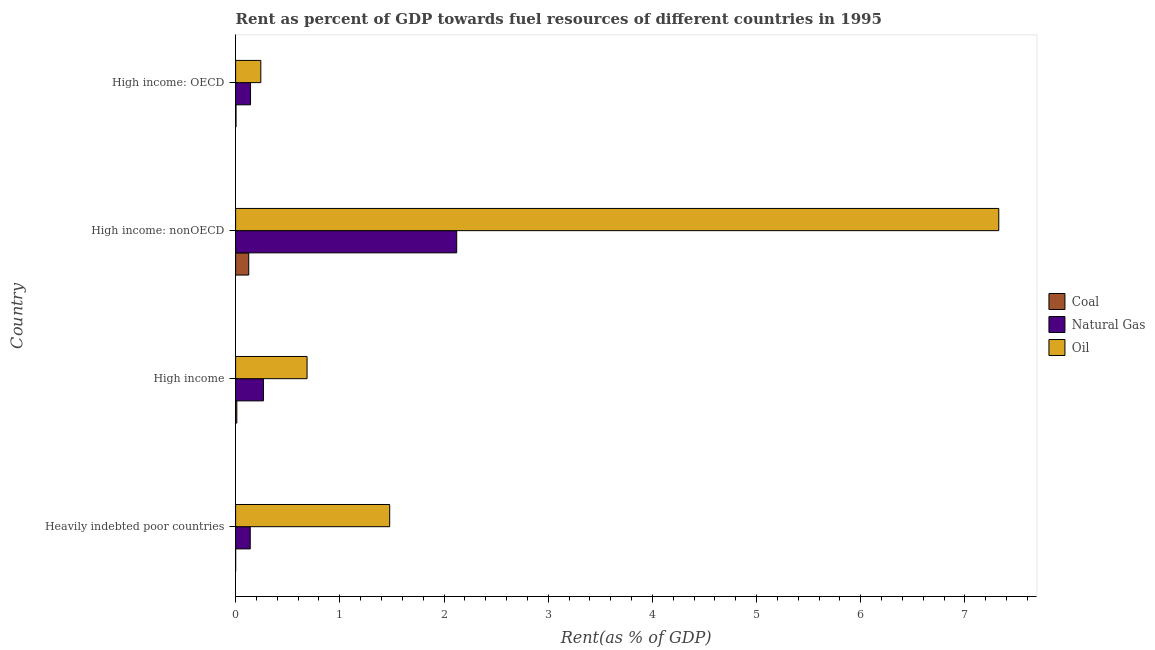How many different coloured bars are there?
Your answer should be compact. 3. How many groups of bars are there?
Your answer should be compact. 4. Are the number of bars per tick equal to the number of legend labels?
Your answer should be very brief. Yes. Are the number of bars on each tick of the Y-axis equal?
Keep it short and to the point. Yes. How many bars are there on the 1st tick from the top?
Provide a short and direct response. 3. What is the label of the 4th group of bars from the top?
Ensure brevity in your answer.  Heavily indebted poor countries. In how many cases, is the number of bars for a given country not equal to the number of legend labels?
Make the answer very short. 0. What is the rent towards natural gas in High income: OECD?
Offer a terse response. 0.14. Across all countries, what is the maximum rent towards coal?
Keep it short and to the point. 0.13. Across all countries, what is the minimum rent towards oil?
Ensure brevity in your answer.  0.24. In which country was the rent towards coal maximum?
Your answer should be compact. High income: nonOECD. In which country was the rent towards natural gas minimum?
Your answer should be very brief. Heavily indebted poor countries. What is the total rent towards coal in the graph?
Your answer should be very brief. 0.14. What is the difference between the rent towards coal in Heavily indebted poor countries and that in High income: nonOECD?
Your answer should be compact. -0.13. What is the difference between the rent towards coal in High income: OECD and the rent towards natural gas in High income: nonOECD?
Give a very brief answer. -2.12. What is the average rent towards natural gas per country?
Ensure brevity in your answer.  0.67. What is the difference between the rent towards coal and rent towards natural gas in High income?
Make the answer very short. -0.26. Is the rent towards coal in High income: OECD less than that in High income: nonOECD?
Your response must be concise. Yes. What is the difference between the highest and the second highest rent towards coal?
Your answer should be very brief. 0.11. What is the difference between the highest and the lowest rent towards natural gas?
Ensure brevity in your answer.  1.98. Is the sum of the rent towards coal in High income: OECD and High income: nonOECD greater than the maximum rent towards natural gas across all countries?
Your answer should be very brief. No. What does the 2nd bar from the top in High income represents?
Provide a succinct answer. Natural Gas. What does the 3rd bar from the bottom in High income represents?
Ensure brevity in your answer.  Oil. How many bars are there?
Provide a succinct answer. 12. Are all the bars in the graph horizontal?
Offer a very short reply. Yes. How many countries are there in the graph?
Provide a short and direct response. 4. Does the graph contain any zero values?
Your answer should be very brief. No. Where does the legend appear in the graph?
Your answer should be compact. Center right. What is the title of the graph?
Your response must be concise. Rent as percent of GDP towards fuel resources of different countries in 1995. What is the label or title of the X-axis?
Make the answer very short. Rent(as % of GDP). What is the label or title of the Y-axis?
Give a very brief answer. Country. What is the Rent(as % of GDP) of Coal in Heavily indebted poor countries?
Offer a terse response. 3.12441298974557e-5. What is the Rent(as % of GDP) of Natural Gas in Heavily indebted poor countries?
Offer a terse response. 0.14. What is the Rent(as % of GDP) in Oil in Heavily indebted poor countries?
Keep it short and to the point. 1.48. What is the Rent(as % of GDP) in Coal in High income?
Give a very brief answer. 0.01. What is the Rent(as % of GDP) of Natural Gas in High income?
Offer a terse response. 0.27. What is the Rent(as % of GDP) in Oil in High income?
Provide a short and direct response. 0.69. What is the Rent(as % of GDP) of Coal in High income: nonOECD?
Your response must be concise. 0.13. What is the Rent(as % of GDP) of Natural Gas in High income: nonOECD?
Offer a very short reply. 2.12. What is the Rent(as % of GDP) in Oil in High income: nonOECD?
Provide a short and direct response. 7.32. What is the Rent(as % of GDP) in Coal in High income: OECD?
Your answer should be very brief. 0. What is the Rent(as % of GDP) in Natural Gas in High income: OECD?
Offer a terse response. 0.14. What is the Rent(as % of GDP) in Oil in High income: OECD?
Provide a short and direct response. 0.24. Across all countries, what is the maximum Rent(as % of GDP) of Coal?
Offer a very short reply. 0.13. Across all countries, what is the maximum Rent(as % of GDP) of Natural Gas?
Your answer should be very brief. 2.12. Across all countries, what is the maximum Rent(as % of GDP) in Oil?
Your answer should be very brief. 7.32. Across all countries, what is the minimum Rent(as % of GDP) in Coal?
Offer a terse response. 3.12441298974557e-5. Across all countries, what is the minimum Rent(as % of GDP) of Natural Gas?
Provide a short and direct response. 0.14. Across all countries, what is the minimum Rent(as % of GDP) of Oil?
Offer a very short reply. 0.24. What is the total Rent(as % of GDP) of Coal in the graph?
Provide a succinct answer. 0.14. What is the total Rent(as % of GDP) of Natural Gas in the graph?
Your response must be concise. 2.67. What is the total Rent(as % of GDP) in Oil in the graph?
Give a very brief answer. 9.73. What is the difference between the Rent(as % of GDP) of Coal in Heavily indebted poor countries and that in High income?
Offer a very short reply. -0.01. What is the difference between the Rent(as % of GDP) in Natural Gas in Heavily indebted poor countries and that in High income?
Your response must be concise. -0.13. What is the difference between the Rent(as % of GDP) of Oil in Heavily indebted poor countries and that in High income?
Provide a succinct answer. 0.79. What is the difference between the Rent(as % of GDP) in Coal in Heavily indebted poor countries and that in High income: nonOECD?
Your answer should be very brief. -0.13. What is the difference between the Rent(as % of GDP) of Natural Gas in Heavily indebted poor countries and that in High income: nonOECD?
Make the answer very short. -1.98. What is the difference between the Rent(as % of GDP) of Oil in Heavily indebted poor countries and that in High income: nonOECD?
Your answer should be very brief. -5.85. What is the difference between the Rent(as % of GDP) in Coal in Heavily indebted poor countries and that in High income: OECD?
Ensure brevity in your answer.  -0. What is the difference between the Rent(as % of GDP) of Natural Gas in Heavily indebted poor countries and that in High income: OECD?
Your response must be concise. -0. What is the difference between the Rent(as % of GDP) in Oil in Heavily indebted poor countries and that in High income: OECD?
Your response must be concise. 1.24. What is the difference between the Rent(as % of GDP) of Coal in High income and that in High income: nonOECD?
Make the answer very short. -0.11. What is the difference between the Rent(as % of GDP) in Natural Gas in High income and that in High income: nonOECD?
Keep it short and to the point. -1.85. What is the difference between the Rent(as % of GDP) in Oil in High income and that in High income: nonOECD?
Your answer should be compact. -6.64. What is the difference between the Rent(as % of GDP) of Coal in High income and that in High income: OECD?
Your response must be concise. 0.01. What is the difference between the Rent(as % of GDP) of Natural Gas in High income and that in High income: OECD?
Your answer should be compact. 0.12. What is the difference between the Rent(as % of GDP) of Oil in High income and that in High income: OECD?
Offer a terse response. 0.44. What is the difference between the Rent(as % of GDP) of Coal in High income: nonOECD and that in High income: OECD?
Offer a very short reply. 0.12. What is the difference between the Rent(as % of GDP) of Natural Gas in High income: nonOECD and that in High income: OECD?
Offer a very short reply. 1.98. What is the difference between the Rent(as % of GDP) of Oil in High income: nonOECD and that in High income: OECD?
Provide a short and direct response. 7.08. What is the difference between the Rent(as % of GDP) of Coal in Heavily indebted poor countries and the Rent(as % of GDP) of Natural Gas in High income?
Make the answer very short. -0.27. What is the difference between the Rent(as % of GDP) in Coal in Heavily indebted poor countries and the Rent(as % of GDP) in Oil in High income?
Provide a succinct answer. -0.69. What is the difference between the Rent(as % of GDP) in Natural Gas in Heavily indebted poor countries and the Rent(as % of GDP) in Oil in High income?
Your response must be concise. -0.55. What is the difference between the Rent(as % of GDP) in Coal in Heavily indebted poor countries and the Rent(as % of GDP) in Natural Gas in High income: nonOECD?
Offer a very short reply. -2.12. What is the difference between the Rent(as % of GDP) in Coal in Heavily indebted poor countries and the Rent(as % of GDP) in Oil in High income: nonOECD?
Ensure brevity in your answer.  -7.32. What is the difference between the Rent(as % of GDP) of Natural Gas in Heavily indebted poor countries and the Rent(as % of GDP) of Oil in High income: nonOECD?
Provide a succinct answer. -7.18. What is the difference between the Rent(as % of GDP) in Coal in Heavily indebted poor countries and the Rent(as % of GDP) in Natural Gas in High income: OECD?
Your answer should be compact. -0.14. What is the difference between the Rent(as % of GDP) of Coal in Heavily indebted poor countries and the Rent(as % of GDP) of Oil in High income: OECD?
Offer a very short reply. -0.24. What is the difference between the Rent(as % of GDP) in Natural Gas in Heavily indebted poor countries and the Rent(as % of GDP) in Oil in High income: OECD?
Make the answer very short. -0.1. What is the difference between the Rent(as % of GDP) of Coal in High income and the Rent(as % of GDP) of Natural Gas in High income: nonOECD?
Provide a short and direct response. -2.11. What is the difference between the Rent(as % of GDP) in Coal in High income and the Rent(as % of GDP) in Oil in High income: nonOECD?
Make the answer very short. -7.31. What is the difference between the Rent(as % of GDP) in Natural Gas in High income and the Rent(as % of GDP) in Oil in High income: nonOECD?
Your answer should be very brief. -7.06. What is the difference between the Rent(as % of GDP) of Coal in High income and the Rent(as % of GDP) of Natural Gas in High income: OECD?
Ensure brevity in your answer.  -0.13. What is the difference between the Rent(as % of GDP) in Coal in High income and the Rent(as % of GDP) in Oil in High income: OECD?
Provide a short and direct response. -0.23. What is the difference between the Rent(as % of GDP) in Natural Gas in High income and the Rent(as % of GDP) in Oil in High income: OECD?
Offer a very short reply. 0.03. What is the difference between the Rent(as % of GDP) in Coal in High income: nonOECD and the Rent(as % of GDP) in Natural Gas in High income: OECD?
Your answer should be very brief. -0.02. What is the difference between the Rent(as % of GDP) of Coal in High income: nonOECD and the Rent(as % of GDP) of Oil in High income: OECD?
Offer a very short reply. -0.12. What is the difference between the Rent(as % of GDP) in Natural Gas in High income: nonOECD and the Rent(as % of GDP) in Oil in High income: OECD?
Give a very brief answer. 1.88. What is the average Rent(as % of GDP) of Coal per country?
Provide a succinct answer. 0.04. What is the average Rent(as % of GDP) of Natural Gas per country?
Make the answer very short. 0.67. What is the average Rent(as % of GDP) in Oil per country?
Offer a very short reply. 2.43. What is the difference between the Rent(as % of GDP) of Coal and Rent(as % of GDP) of Natural Gas in Heavily indebted poor countries?
Your response must be concise. -0.14. What is the difference between the Rent(as % of GDP) of Coal and Rent(as % of GDP) of Oil in Heavily indebted poor countries?
Ensure brevity in your answer.  -1.48. What is the difference between the Rent(as % of GDP) in Natural Gas and Rent(as % of GDP) in Oil in Heavily indebted poor countries?
Give a very brief answer. -1.34. What is the difference between the Rent(as % of GDP) in Coal and Rent(as % of GDP) in Natural Gas in High income?
Give a very brief answer. -0.26. What is the difference between the Rent(as % of GDP) in Coal and Rent(as % of GDP) in Oil in High income?
Ensure brevity in your answer.  -0.67. What is the difference between the Rent(as % of GDP) in Natural Gas and Rent(as % of GDP) in Oil in High income?
Ensure brevity in your answer.  -0.42. What is the difference between the Rent(as % of GDP) of Coal and Rent(as % of GDP) of Natural Gas in High income: nonOECD?
Make the answer very short. -2. What is the difference between the Rent(as % of GDP) in Coal and Rent(as % of GDP) in Oil in High income: nonOECD?
Your answer should be very brief. -7.2. What is the difference between the Rent(as % of GDP) in Natural Gas and Rent(as % of GDP) in Oil in High income: nonOECD?
Make the answer very short. -5.2. What is the difference between the Rent(as % of GDP) in Coal and Rent(as % of GDP) in Natural Gas in High income: OECD?
Your response must be concise. -0.14. What is the difference between the Rent(as % of GDP) in Coal and Rent(as % of GDP) in Oil in High income: OECD?
Offer a terse response. -0.24. What is the difference between the Rent(as % of GDP) of Natural Gas and Rent(as % of GDP) of Oil in High income: OECD?
Keep it short and to the point. -0.1. What is the ratio of the Rent(as % of GDP) of Coal in Heavily indebted poor countries to that in High income?
Provide a succinct answer. 0. What is the ratio of the Rent(as % of GDP) of Natural Gas in Heavily indebted poor countries to that in High income?
Make the answer very short. 0.53. What is the ratio of the Rent(as % of GDP) of Oil in Heavily indebted poor countries to that in High income?
Your response must be concise. 2.16. What is the ratio of the Rent(as % of GDP) in Natural Gas in Heavily indebted poor countries to that in High income: nonOECD?
Give a very brief answer. 0.07. What is the ratio of the Rent(as % of GDP) in Oil in Heavily indebted poor countries to that in High income: nonOECD?
Your answer should be compact. 0.2. What is the ratio of the Rent(as % of GDP) in Coal in Heavily indebted poor countries to that in High income: OECD?
Your response must be concise. 0.01. What is the ratio of the Rent(as % of GDP) in Natural Gas in Heavily indebted poor countries to that in High income: OECD?
Provide a succinct answer. 0.98. What is the ratio of the Rent(as % of GDP) in Oil in Heavily indebted poor countries to that in High income: OECD?
Your answer should be compact. 6.11. What is the ratio of the Rent(as % of GDP) in Coal in High income to that in High income: nonOECD?
Give a very brief answer. 0.09. What is the ratio of the Rent(as % of GDP) in Natural Gas in High income to that in High income: nonOECD?
Provide a short and direct response. 0.13. What is the ratio of the Rent(as % of GDP) in Oil in High income to that in High income: nonOECD?
Keep it short and to the point. 0.09. What is the ratio of the Rent(as % of GDP) of Coal in High income to that in High income: OECD?
Offer a very short reply. 2.95. What is the ratio of the Rent(as % of GDP) in Natural Gas in High income to that in High income: OECD?
Your answer should be very brief. 1.87. What is the ratio of the Rent(as % of GDP) in Oil in High income to that in High income: OECD?
Your answer should be very brief. 2.84. What is the ratio of the Rent(as % of GDP) of Coal in High income: nonOECD to that in High income: OECD?
Offer a very short reply. 32.12. What is the ratio of the Rent(as % of GDP) in Natural Gas in High income: nonOECD to that in High income: OECD?
Your answer should be very brief. 14.83. What is the ratio of the Rent(as % of GDP) of Oil in High income: nonOECD to that in High income: OECD?
Your response must be concise. 30.29. What is the difference between the highest and the second highest Rent(as % of GDP) in Coal?
Offer a very short reply. 0.11. What is the difference between the highest and the second highest Rent(as % of GDP) in Natural Gas?
Make the answer very short. 1.85. What is the difference between the highest and the second highest Rent(as % of GDP) in Oil?
Provide a succinct answer. 5.85. What is the difference between the highest and the lowest Rent(as % of GDP) of Coal?
Your answer should be compact. 0.13. What is the difference between the highest and the lowest Rent(as % of GDP) of Natural Gas?
Provide a succinct answer. 1.98. What is the difference between the highest and the lowest Rent(as % of GDP) of Oil?
Your response must be concise. 7.08. 